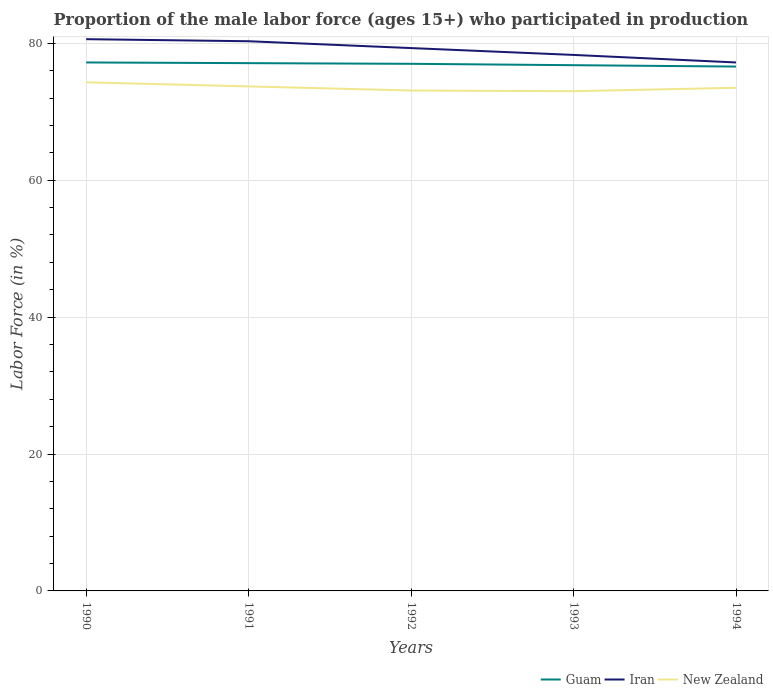Does the line corresponding to New Zealand intersect with the line corresponding to Guam?
Keep it short and to the point. No. Across all years, what is the maximum proportion of the male labor force who participated in production in New Zealand?
Ensure brevity in your answer.  73. What is the total proportion of the male labor force who participated in production in New Zealand in the graph?
Provide a short and direct response. 0.6. What is the difference between the highest and the second highest proportion of the male labor force who participated in production in Iran?
Your answer should be compact. 3.4. Is the proportion of the male labor force who participated in production in New Zealand strictly greater than the proportion of the male labor force who participated in production in Iran over the years?
Provide a short and direct response. Yes. How many years are there in the graph?
Offer a very short reply. 5. What is the difference between two consecutive major ticks on the Y-axis?
Offer a terse response. 20. Are the values on the major ticks of Y-axis written in scientific E-notation?
Make the answer very short. No. Does the graph contain any zero values?
Offer a very short reply. No. Does the graph contain grids?
Your response must be concise. Yes. Where does the legend appear in the graph?
Make the answer very short. Bottom right. How many legend labels are there?
Provide a short and direct response. 3. How are the legend labels stacked?
Ensure brevity in your answer.  Horizontal. What is the title of the graph?
Ensure brevity in your answer.  Proportion of the male labor force (ages 15+) who participated in production. What is the label or title of the X-axis?
Provide a succinct answer. Years. What is the Labor Force (in %) in Guam in 1990?
Offer a very short reply. 77.2. What is the Labor Force (in %) of Iran in 1990?
Give a very brief answer. 80.6. What is the Labor Force (in %) of New Zealand in 1990?
Make the answer very short. 74.3. What is the Labor Force (in %) in Guam in 1991?
Offer a terse response. 77.1. What is the Labor Force (in %) of Iran in 1991?
Offer a very short reply. 80.3. What is the Labor Force (in %) in New Zealand in 1991?
Your answer should be very brief. 73.7. What is the Labor Force (in %) of Guam in 1992?
Give a very brief answer. 77. What is the Labor Force (in %) in Iran in 1992?
Keep it short and to the point. 79.3. What is the Labor Force (in %) of New Zealand in 1992?
Give a very brief answer. 73.1. What is the Labor Force (in %) in Guam in 1993?
Ensure brevity in your answer.  76.8. What is the Labor Force (in %) in Iran in 1993?
Make the answer very short. 78.3. What is the Labor Force (in %) in New Zealand in 1993?
Offer a very short reply. 73. What is the Labor Force (in %) of Guam in 1994?
Ensure brevity in your answer.  76.6. What is the Labor Force (in %) in Iran in 1994?
Make the answer very short. 77.2. What is the Labor Force (in %) of New Zealand in 1994?
Provide a short and direct response. 73.5. Across all years, what is the maximum Labor Force (in %) in Guam?
Give a very brief answer. 77.2. Across all years, what is the maximum Labor Force (in %) in Iran?
Make the answer very short. 80.6. Across all years, what is the maximum Labor Force (in %) in New Zealand?
Your answer should be compact. 74.3. Across all years, what is the minimum Labor Force (in %) in Guam?
Keep it short and to the point. 76.6. Across all years, what is the minimum Labor Force (in %) of Iran?
Offer a very short reply. 77.2. What is the total Labor Force (in %) in Guam in the graph?
Keep it short and to the point. 384.7. What is the total Labor Force (in %) of Iran in the graph?
Give a very brief answer. 395.7. What is the total Labor Force (in %) of New Zealand in the graph?
Provide a succinct answer. 367.6. What is the difference between the Labor Force (in %) of Iran in 1990 and that in 1991?
Provide a short and direct response. 0.3. What is the difference between the Labor Force (in %) in Guam in 1990 and that in 1992?
Give a very brief answer. 0.2. What is the difference between the Labor Force (in %) in Iran in 1990 and that in 1992?
Your answer should be compact. 1.3. What is the difference between the Labor Force (in %) of Guam in 1990 and that in 1993?
Keep it short and to the point. 0.4. What is the difference between the Labor Force (in %) in New Zealand in 1990 and that in 1994?
Your response must be concise. 0.8. What is the difference between the Labor Force (in %) of Guam in 1991 and that in 1992?
Keep it short and to the point. 0.1. What is the difference between the Labor Force (in %) of Guam in 1991 and that in 1993?
Make the answer very short. 0.3. What is the difference between the Labor Force (in %) in Iran in 1991 and that in 1993?
Make the answer very short. 2. What is the difference between the Labor Force (in %) of New Zealand in 1991 and that in 1993?
Your response must be concise. 0.7. What is the difference between the Labor Force (in %) in New Zealand in 1991 and that in 1994?
Your answer should be compact. 0.2. What is the difference between the Labor Force (in %) in Iran in 1992 and that in 1993?
Offer a very short reply. 1. What is the difference between the Labor Force (in %) in Guam in 1992 and that in 1994?
Ensure brevity in your answer.  0.4. What is the difference between the Labor Force (in %) of New Zealand in 1992 and that in 1994?
Your answer should be compact. -0.4. What is the difference between the Labor Force (in %) of Guam in 1993 and that in 1994?
Your response must be concise. 0.2. What is the difference between the Labor Force (in %) in New Zealand in 1993 and that in 1994?
Provide a short and direct response. -0.5. What is the difference between the Labor Force (in %) in Guam in 1990 and the Labor Force (in %) in Iran in 1991?
Ensure brevity in your answer.  -3.1. What is the difference between the Labor Force (in %) in Guam in 1990 and the Labor Force (in %) in New Zealand in 1991?
Offer a terse response. 3.5. What is the difference between the Labor Force (in %) in Iran in 1990 and the Labor Force (in %) in New Zealand in 1991?
Ensure brevity in your answer.  6.9. What is the difference between the Labor Force (in %) in Guam in 1990 and the Labor Force (in %) in New Zealand in 1993?
Offer a terse response. 4.2. What is the difference between the Labor Force (in %) in Iran in 1990 and the Labor Force (in %) in New Zealand in 1993?
Offer a terse response. 7.6. What is the difference between the Labor Force (in %) in Guam in 1990 and the Labor Force (in %) in Iran in 1994?
Provide a succinct answer. 0. What is the difference between the Labor Force (in %) in Guam in 1990 and the Labor Force (in %) in New Zealand in 1994?
Keep it short and to the point. 3.7. What is the difference between the Labor Force (in %) of Guam in 1991 and the Labor Force (in %) of New Zealand in 1992?
Your answer should be very brief. 4. What is the difference between the Labor Force (in %) of Guam in 1991 and the Labor Force (in %) of Iran in 1993?
Offer a very short reply. -1.2. What is the difference between the Labor Force (in %) in Guam in 1991 and the Labor Force (in %) in New Zealand in 1993?
Offer a very short reply. 4.1. What is the difference between the Labor Force (in %) in Guam in 1991 and the Labor Force (in %) in Iran in 1994?
Offer a terse response. -0.1. What is the difference between the Labor Force (in %) in Guam in 1991 and the Labor Force (in %) in New Zealand in 1994?
Your response must be concise. 3.6. What is the difference between the Labor Force (in %) of Iran in 1991 and the Labor Force (in %) of New Zealand in 1994?
Your answer should be very brief. 6.8. What is the difference between the Labor Force (in %) in Guam in 1992 and the Labor Force (in %) in New Zealand in 1993?
Provide a short and direct response. 4. What is the difference between the Labor Force (in %) in Iran in 1992 and the Labor Force (in %) in New Zealand in 1993?
Keep it short and to the point. 6.3. What is the difference between the Labor Force (in %) of Guam in 1992 and the Labor Force (in %) of Iran in 1994?
Your response must be concise. -0.2. What is the difference between the Labor Force (in %) of Guam in 1992 and the Labor Force (in %) of New Zealand in 1994?
Your answer should be compact. 3.5. What is the difference between the Labor Force (in %) in Guam in 1993 and the Labor Force (in %) in Iran in 1994?
Make the answer very short. -0.4. What is the difference between the Labor Force (in %) in Guam in 1993 and the Labor Force (in %) in New Zealand in 1994?
Your answer should be compact. 3.3. What is the average Labor Force (in %) of Guam per year?
Your response must be concise. 76.94. What is the average Labor Force (in %) in Iran per year?
Offer a terse response. 79.14. What is the average Labor Force (in %) in New Zealand per year?
Provide a short and direct response. 73.52. In the year 1991, what is the difference between the Labor Force (in %) in Guam and Labor Force (in %) in Iran?
Your response must be concise. -3.2. In the year 1991, what is the difference between the Labor Force (in %) in Guam and Labor Force (in %) in New Zealand?
Keep it short and to the point. 3.4. In the year 1992, what is the difference between the Labor Force (in %) of Guam and Labor Force (in %) of Iran?
Provide a short and direct response. -2.3. In the year 1992, what is the difference between the Labor Force (in %) of Guam and Labor Force (in %) of New Zealand?
Your answer should be compact. 3.9. In the year 1992, what is the difference between the Labor Force (in %) in Iran and Labor Force (in %) in New Zealand?
Make the answer very short. 6.2. In the year 1993, what is the difference between the Labor Force (in %) in Iran and Labor Force (in %) in New Zealand?
Keep it short and to the point. 5.3. In the year 1994, what is the difference between the Labor Force (in %) in Guam and Labor Force (in %) in Iran?
Provide a succinct answer. -0.6. What is the ratio of the Labor Force (in %) in Iran in 1990 to that in 1991?
Give a very brief answer. 1. What is the ratio of the Labor Force (in %) of Iran in 1990 to that in 1992?
Make the answer very short. 1.02. What is the ratio of the Labor Force (in %) in New Zealand in 1990 to that in 1992?
Give a very brief answer. 1.02. What is the ratio of the Labor Force (in %) in Guam in 1990 to that in 1993?
Your answer should be compact. 1.01. What is the ratio of the Labor Force (in %) of Iran in 1990 to that in 1993?
Offer a very short reply. 1.03. What is the ratio of the Labor Force (in %) in New Zealand in 1990 to that in 1993?
Ensure brevity in your answer.  1.02. What is the ratio of the Labor Force (in %) of Iran in 1990 to that in 1994?
Provide a short and direct response. 1.04. What is the ratio of the Labor Force (in %) of New Zealand in 1990 to that in 1994?
Provide a succinct answer. 1.01. What is the ratio of the Labor Force (in %) in Iran in 1991 to that in 1992?
Make the answer very short. 1.01. What is the ratio of the Labor Force (in %) of New Zealand in 1991 to that in 1992?
Provide a succinct answer. 1.01. What is the ratio of the Labor Force (in %) in Iran in 1991 to that in 1993?
Your response must be concise. 1.03. What is the ratio of the Labor Force (in %) of New Zealand in 1991 to that in 1993?
Give a very brief answer. 1.01. What is the ratio of the Labor Force (in %) in Guam in 1991 to that in 1994?
Your answer should be very brief. 1.01. What is the ratio of the Labor Force (in %) in Iran in 1991 to that in 1994?
Your answer should be very brief. 1.04. What is the ratio of the Labor Force (in %) of Iran in 1992 to that in 1993?
Your answer should be very brief. 1.01. What is the ratio of the Labor Force (in %) in New Zealand in 1992 to that in 1993?
Offer a terse response. 1. What is the ratio of the Labor Force (in %) in Iran in 1992 to that in 1994?
Provide a succinct answer. 1.03. What is the ratio of the Labor Force (in %) in Iran in 1993 to that in 1994?
Make the answer very short. 1.01. What is the difference between the highest and the second highest Labor Force (in %) in Guam?
Your response must be concise. 0.1. What is the difference between the highest and the second highest Labor Force (in %) of Iran?
Your answer should be very brief. 0.3. What is the difference between the highest and the lowest Labor Force (in %) of Iran?
Your answer should be very brief. 3.4. What is the difference between the highest and the lowest Labor Force (in %) in New Zealand?
Ensure brevity in your answer.  1.3. 